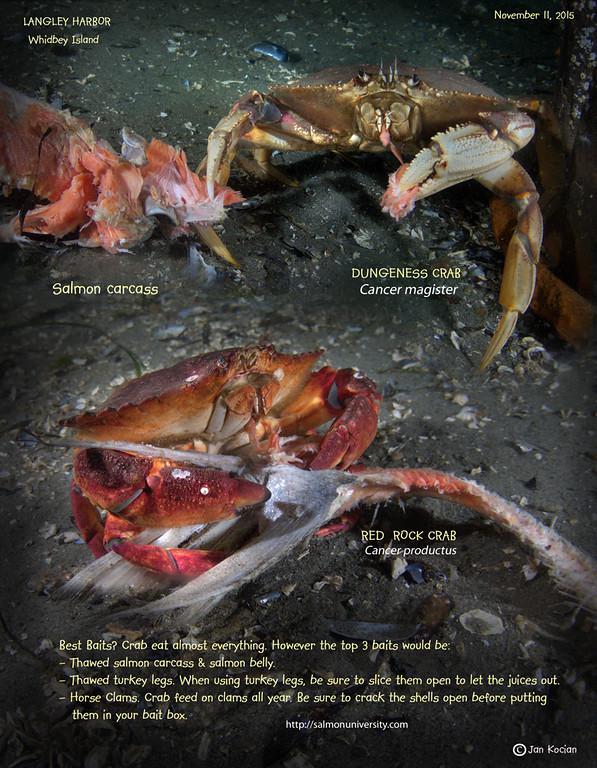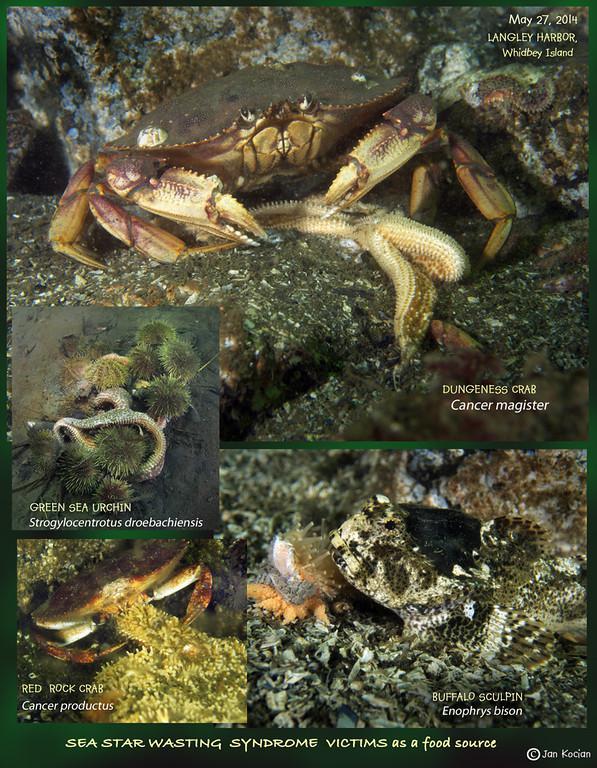The first image is the image on the left, the second image is the image on the right. Given the left and right images, does the statement "One image shows one forward-facing crab with a bright purple shell, and no image contains more than two crabs." hold true? Answer yes or no. No. The first image is the image on the left, the second image is the image on the right. Assess this claim about the two images: "In at least one image there is a single purple headed crab crawling in the ground.". Correct or not? Answer yes or no. No. 